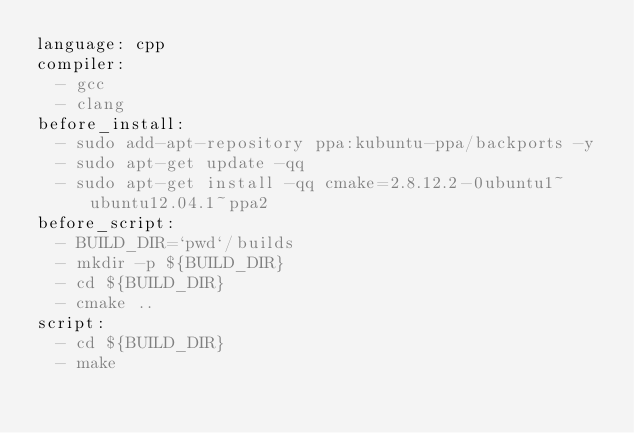<code> <loc_0><loc_0><loc_500><loc_500><_YAML_>language: cpp
compiler:
  - gcc
  - clang
before_install:
  - sudo add-apt-repository ppa:kubuntu-ppa/backports -y
  - sudo apt-get update -qq
  - sudo apt-get install -qq cmake=2.8.12.2-0ubuntu1~ubuntu12.04.1~ppa2
before_script:
  - BUILD_DIR=`pwd`/builds
  - mkdir -p ${BUILD_DIR}
  - cd ${BUILD_DIR}
  - cmake ..
script:
  - cd ${BUILD_DIR}
  - make
</code> 